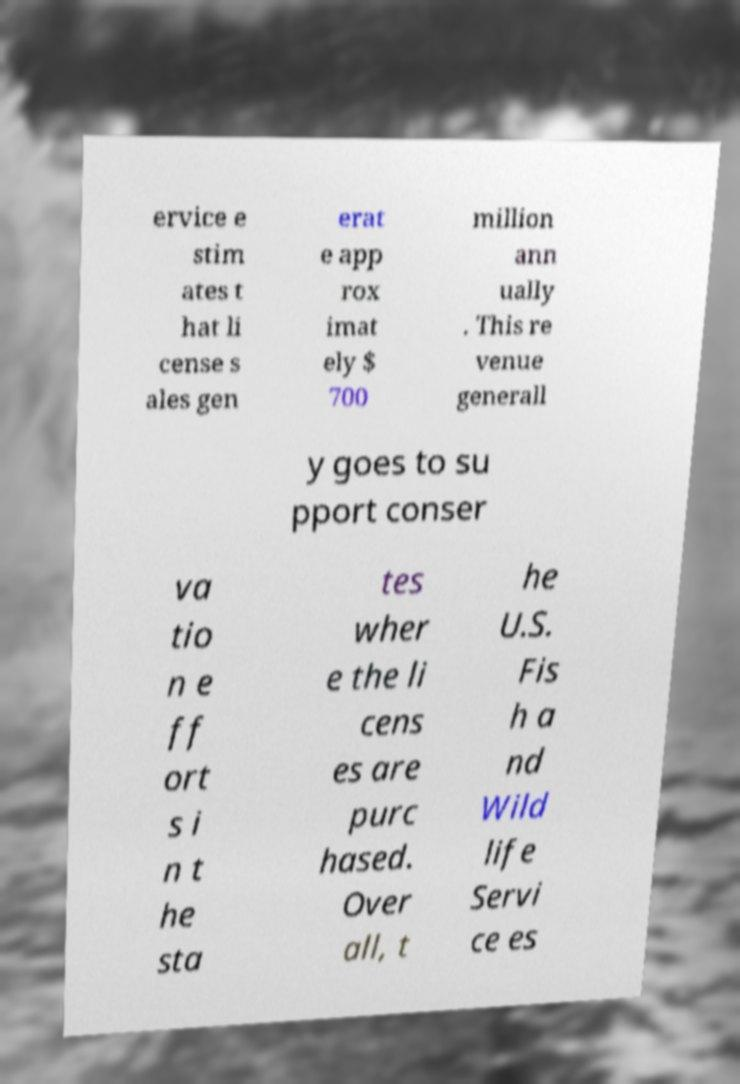Could you extract and type out the text from this image? ervice e stim ates t hat li cense s ales gen erat e app rox imat ely $ 700 million ann ually . This re venue generall y goes to su pport conser va tio n e ff ort s i n t he sta tes wher e the li cens es are purc hased. Over all, t he U.S. Fis h a nd Wild life Servi ce es 